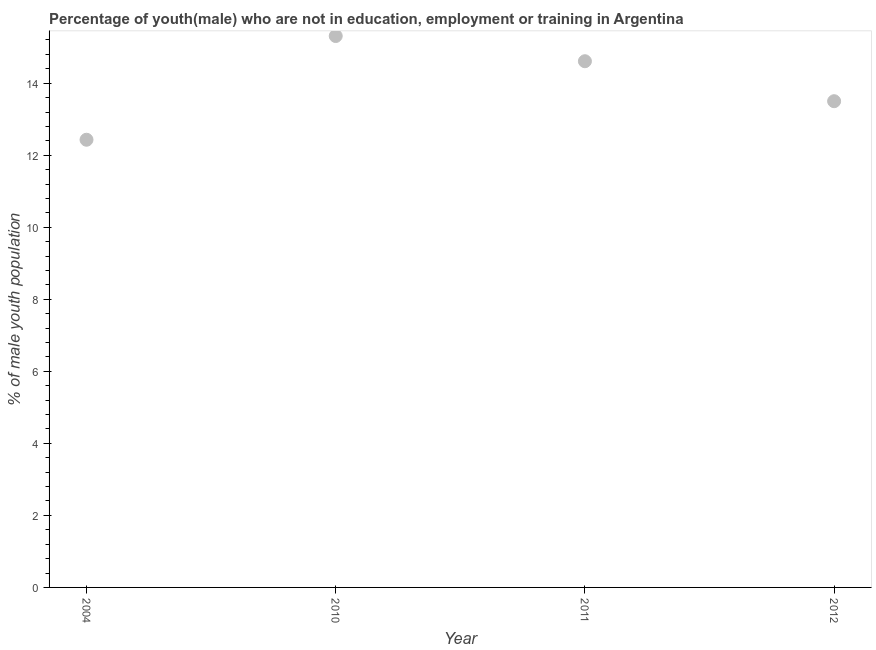What is the unemployed male youth population in 2011?
Offer a very short reply. 14.61. Across all years, what is the maximum unemployed male youth population?
Ensure brevity in your answer.  15.31. Across all years, what is the minimum unemployed male youth population?
Keep it short and to the point. 12.43. In which year was the unemployed male youth population maximum?
Give a very brief answer. 2010. In which year was the unemployed male youth population minimum?
Offer a terse response. 2004. What is the sum of the unemployed male youth population?
Your answer should be very brief. 55.85. What is the difference between the unemployed male youth population in 2004 and 2010?
Offer a very short reply. -2.88. What is the average unemployed male youth population per year?
Ensure brevity in your answer.  13.96. What is the median unemployed male youth population?
Make the answer very short. 14.05. In how many years, is the unemployed male youth population greater than 4.4 %?
Offer a terse response. 4. What is the ratio of the unemployed male youth population in 2011 to that in 2012?
Keep it short and to the point. 1.08. Is the unemployed male youth population in 2004 less than that in 2011?
Provide a succinct answer. Yes. What is the difference between the highest and the second highest unemployed male youth population?
Your response must be concise. 0.7. What is the difference between the highest and the lowest unemployed male youth population?
Offer a very short reply. 2.88. In how many years, is the unemployed male youth population greater than the average unemployed male youth population taken over all years?
Give a very brief answer. 2. Does the unemployed male youth population monotonically increase over the years?
Provide a succinct answer. No. Are the values on the major ticks of Y-axis written in scientific E-notation?
Give a very brief answer. No. What is the title of the graph?
Make the answer very short. Percentage of youth(male) who are not in education, employment or training in Argentina. What is the label or title of the Y-axis?
Your answer should be compact. % of male youth population. What is the % of male youth population in 2004?
Offer a very short reply. 12.43. What is the % of male youth population in 2010?
Give a very brief answer. 15.31. What is the % of male youth population in 2011?
Your answer should be very brief. 14.61. What is the difference between the % of male youth population in 2004 and 2010?
Ensure brevity in your answer.  -2.88. What is the difference between the % of male youth population in 2004 and 2011?
Provide a succinct answer. -2.18. What is the difference between the % of male youth population in 2004 and 2012?
Your answer should be compact. -1.07. What is the difference between the % of male youth population in 2010 and 2012?
Your answer should be compact. 1.81. What is the difference between the % of male youth population in 2011 and 2012?
Make the answer very short. 1.11. What is the ratio of the % of male youth population in 2004 to that in 2010?
Offer a very short reply. 0.81. What is the ratio of the % of male youth population in 2004 to that in 2011?
Provide a succinct answer. 0.85. What is the ratio of the % of male youth population in 2004 to that in 2012?
Your answer should be very brief. 0.92. What is the ratio of the % of male youth population in 2010 to that in 2011?
Ensure brevity in your answer.  1.05. What is the ratio of the % of male youth population in 2010 to that in 2012?
Give a very brief answer. 1.13. What is the ratio of the % of male youth population in 2011 to that in 2012?
Make the answer very short. 1.08. 